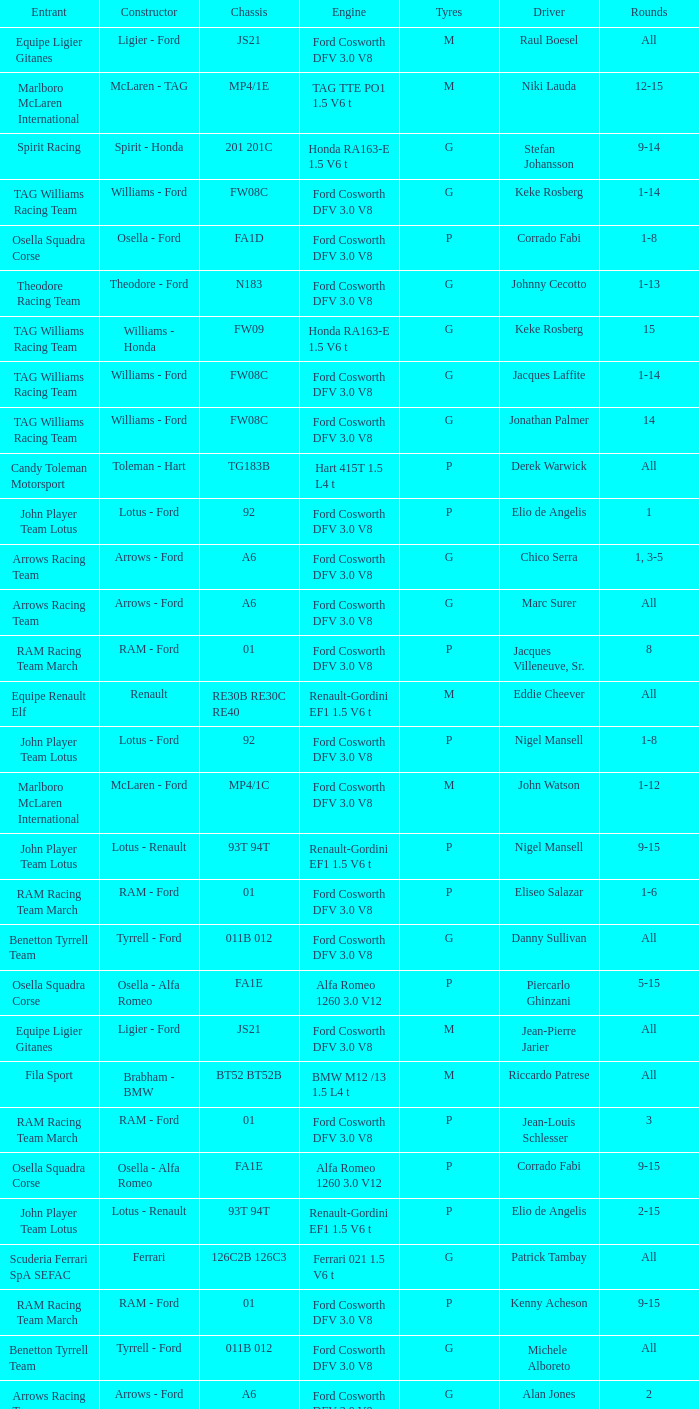Who is the constructor for driver Niki Lauda and a chassis of mp4/1c? McLaren - Ford. 